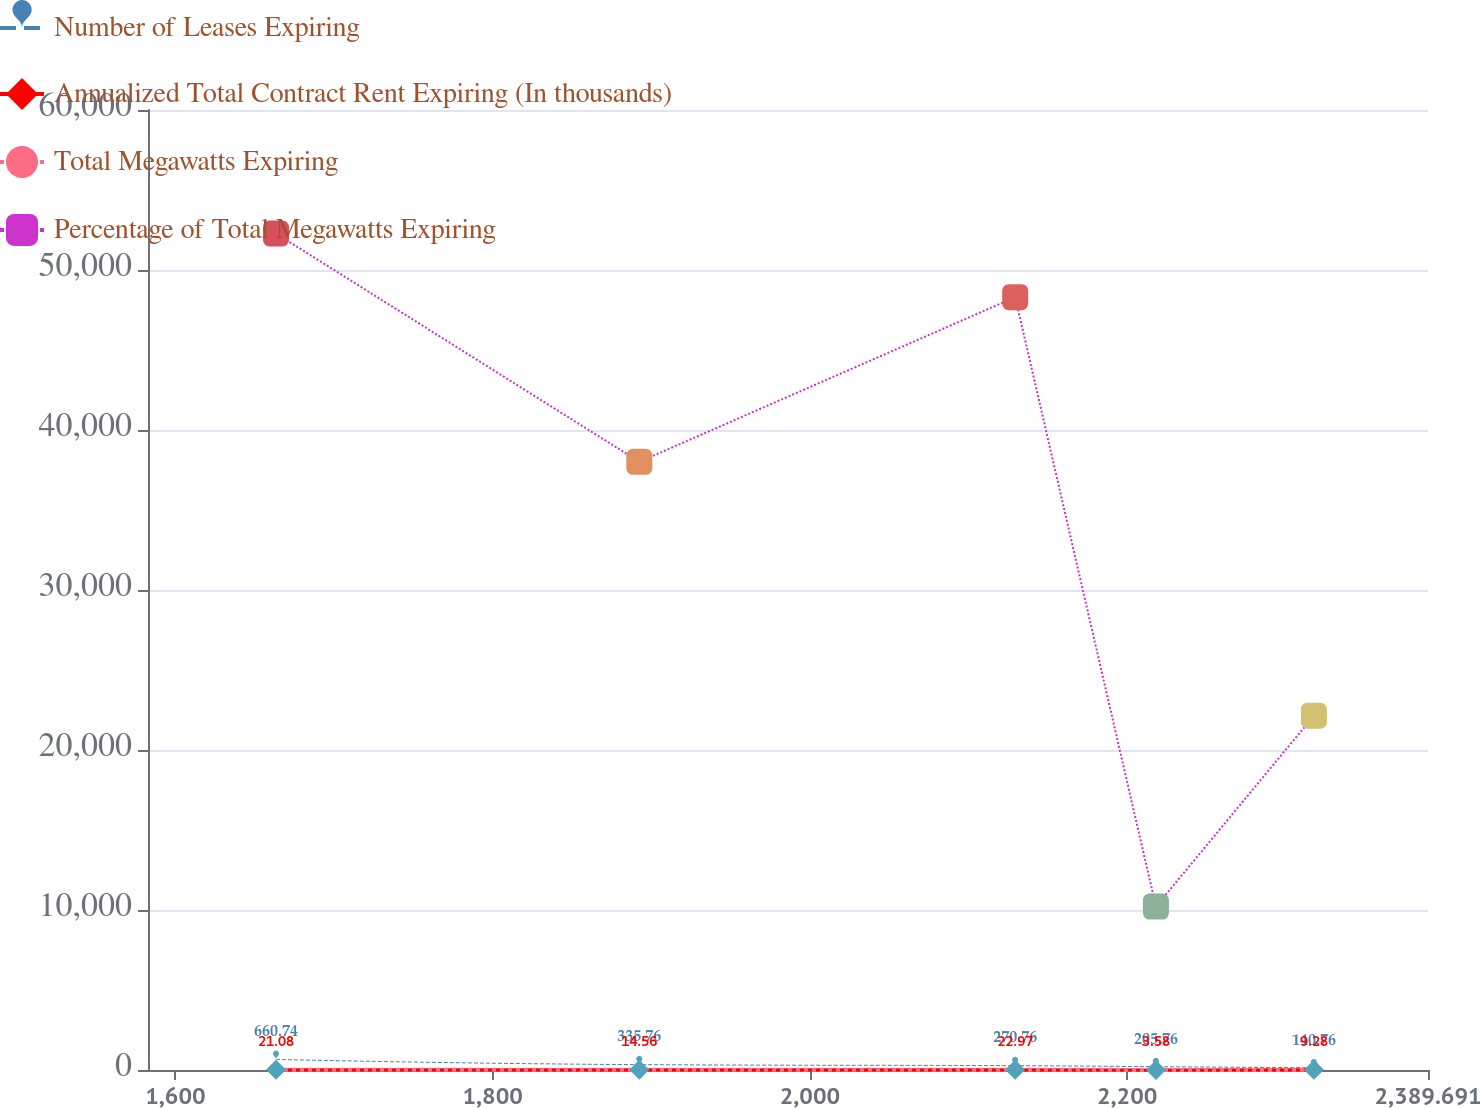<chart> <loc_0><loc_0><loc_500><loc_500><line_chart><ecel><fcel>Number of Leases Expiring<fcel>Annualized Total Contract Rent Expiring (In thousands)<fcel>Total Megawatts Expiring<fcel>Percentage of Total Megawatts Expiring<nl><fcel>1663.4<fcel>660.74<fcel>21.08<fcel>16.56<fcel>52280.5<nl><fcel>1892.46<fcel>335.76<fcel>14.56<fcel>12.16<fcel>38011.4<nl><fcel>2129.44<fcel>270.76<fcel>22.97<fcel>19.85<fcel>48303.9<nl><fcel>2218.15<fcel>205.76<fcel>3.58<fcel>3.1<fcel>10214.7<nl><fcel>2317.77<fcel>140.76<fcel>9.28<fcel>9.09<fcel>22144.4<nl><fcel>2394.08<fcel>75.76<fcel>7.38<fcel>6.46<fcel>18167.8<nl><fcel>2470.39<fcel>10.76<fcel>5.48<fcel>4.78<fcel>14191.3<nl></chart> 